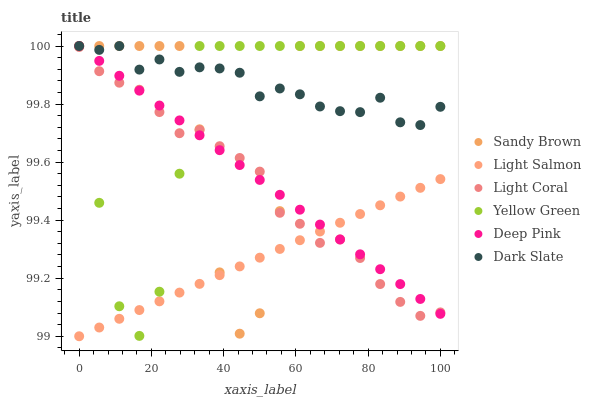Does Light Salmon have the minimum area under the curve?
Answer yes or no. Yes. Does Dark Slate have the maximum area under the curve?
Answer yes or no. Yes. Does Deep Pink have the minimum area under the curve?
Answer yes or no. No. Does Deep Pink have the maximum area under the curve?
Answer yes or no. No. Is Deep Pink the smoothest?
Answer yes or no. Yes. Is Sandy Brown the roughest?
Answer yes or no. Yes. Is Yellow Green the smoothest?
Answer yes or no. No. Is Yellow Green the roughest?
Answer yes or no. No. Does Light Salmon have the lowest value?
Answer yes or no. Yes. Does Deep Pink have the lowest value?
Answer yes or no. No. Does Sandy Brown have the highest value?
Answer yes or no. Yes. Does Light Coral have the highest value?
Answer yes or no. No. Is Light Salmon less than Dark Slate?
Answer yes or no. Yes. Is Dark Slate greater than Light Salmon?
Answer yes or no. Yes. Does Dark Slate intersect Yellow Green?
Answer yes or no. Yes. Is Dark Slate less than Yellow Green?
Answer yes or no. No. Is Dark Slate greater than Yellow Green?
Answer yes or no. No. Does Light Salmon intersect Dark Slate?
Answer yes or no. No. 